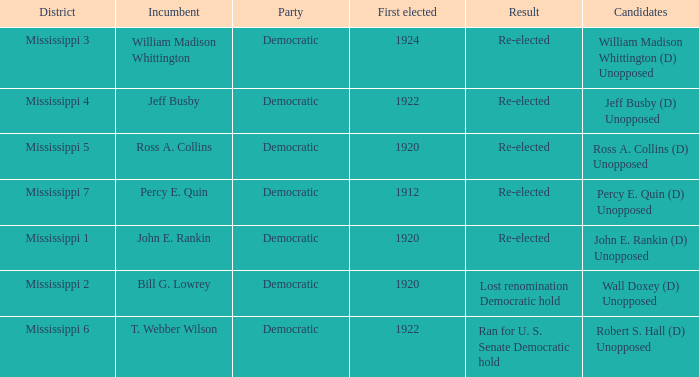What was the result of the election featuring william madison whittington? Re-elected. 